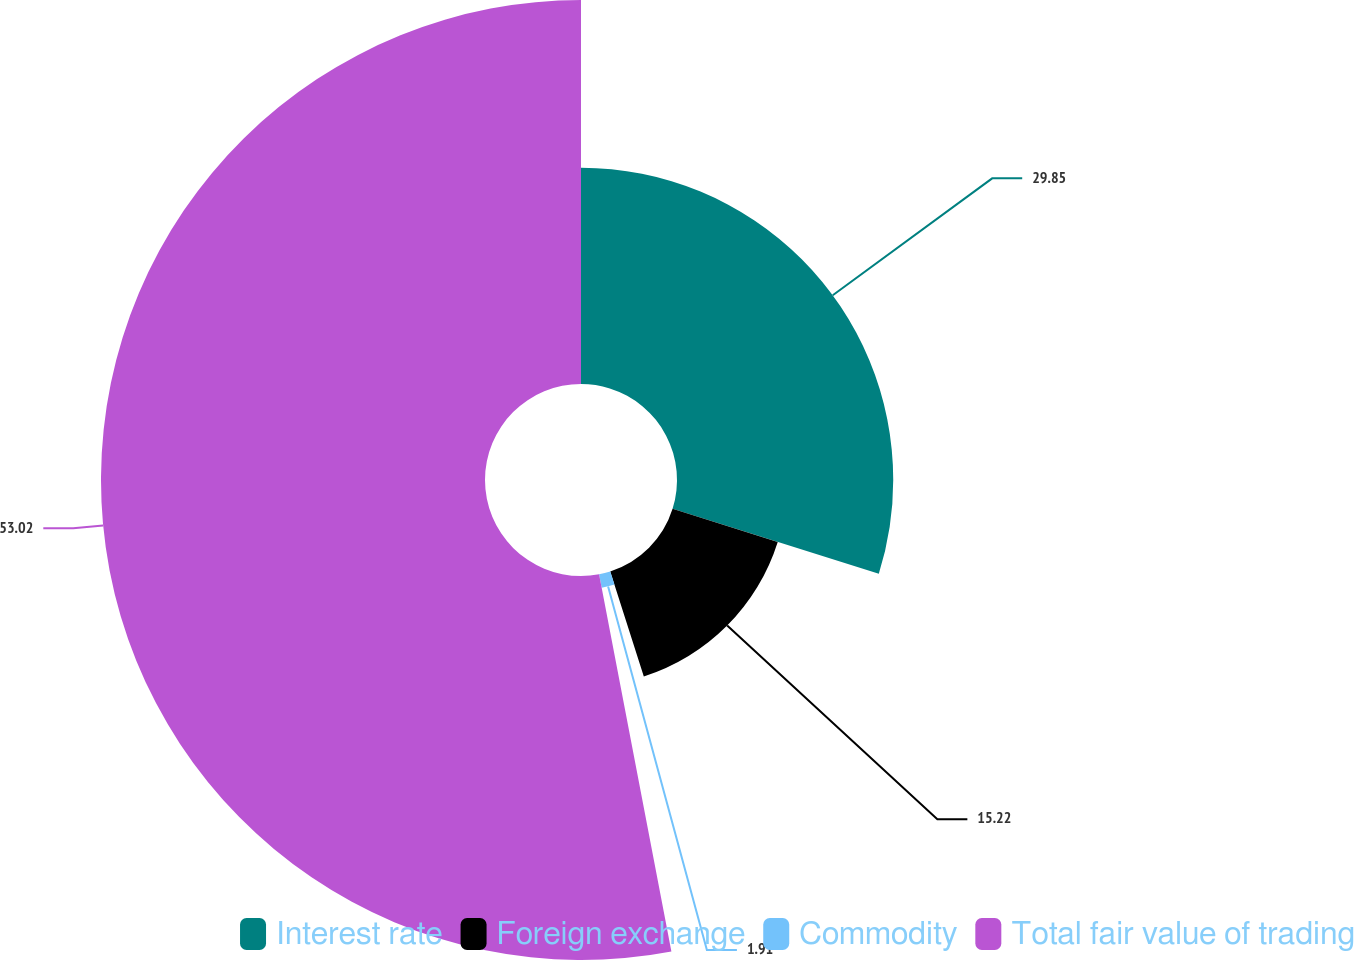Convert chart. <chart><loc_0><loc_0><loc_500><loc_500><pie_chart><fcel>Interest rate<fcel>Foreign exchange<fcel>Commodity<fcel>Total fair value of trading<nl><fcel>29.85%<fcel>15.22%<fcel>1.91%<fcel>53.01%<nl></chart> 